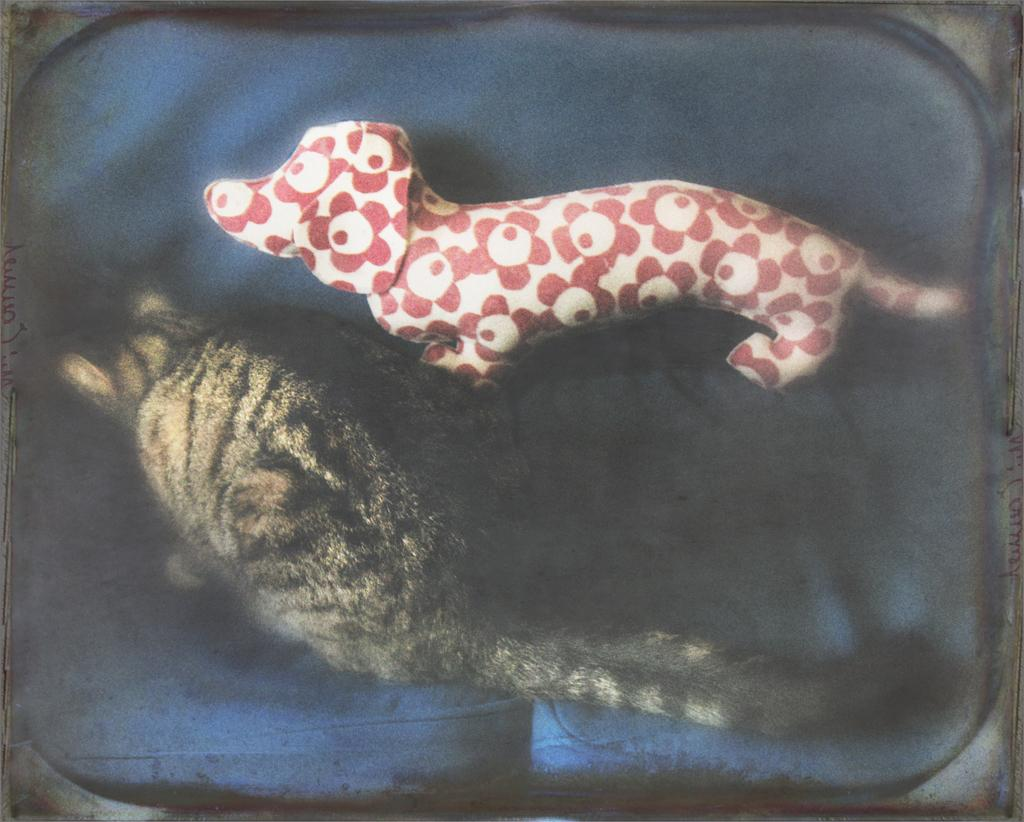What animal can be seen in the image? There is a cat in the image. Where is the cat located? The cat is sitting on a sofa. What object is beside the cat? There is a toy dog beside the cat. What type of mass is visible in the image? There is no mass visible in the image; it features a cat sitting on a sofa with a toy dog beside it. Can you hear the cat laughing in the image? The image is silent, and there is no indication of the cat laughing. 